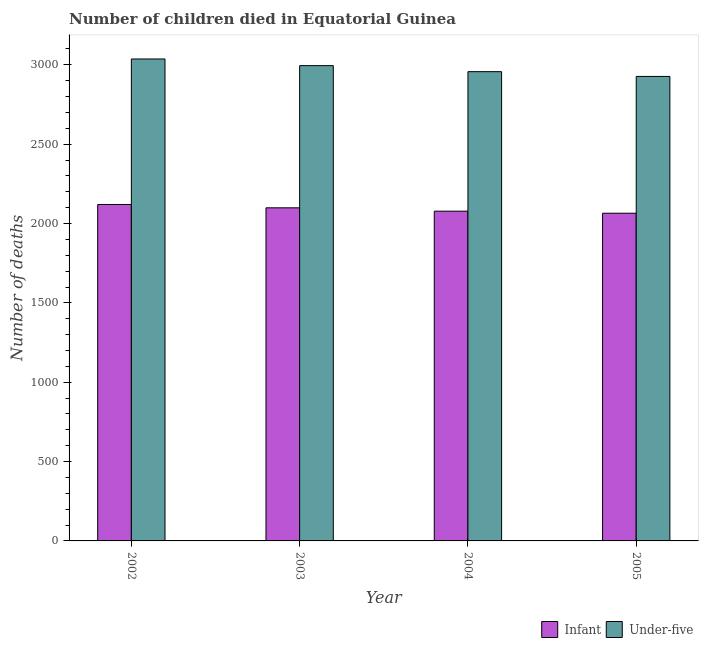How many different coloured bars are there?
Offer a very short reply. 2. How many groups of bars are there?
Make the answer very short. 4. What is the number of infant deaths in 2003?
Your answer should be very brief. 2099. Across all years, what is the maximum number of infant deaths?
Provide a succinct answer. 2120. Across all years, what is the minimum number of infant deaths?
Your response must be concise. 2065. In which year was the number of under-five deaths maximum?
Provide a succinct answer. 2002. In which year was the number of under-five deaths minimum?
Ensure brevity in your answer.  2005. What is the total number of infant deaths in the graph?
Give a very brief answer. 8362. What is the difference between the number of infant deaths in 2002 and that in 2004?
Ensure brevity in your answer.  42. What is the difference between the number of under-five deaths in 2005 and the number of infant deaths in 2004?
Keep it short and to the point. -30. What is the average number of infant deaths per year?
Offer a very short reply. 2090.5. In how many years, is the number of infant deaths greater than 2700?
Keep it short and to the point. 0. What is the ratio of the number of infant deaths in 2002 to that in 2003?
Your answer should be compact. 1.01. Is the difference between the number of infant deaths in 2003 and 2004 greater than the difference between the number of under-five deaths in 2003 and 2004?
Make the answer very short. No. What is the difference between the highest and the lowest number of infant deaths?
Make the answer very short. 55. Is the sum of the number of infant deaths in 2002 and 2005 greater than the maximum number of under-five deaths across all years?
Your answer should be compact. Yes. What does the 1st bar from the left in 2002 represents?
Give a very brief answer. Infant. What does the 1st bar from the right in 2003 represents?
Give a very brief answer. Under-five. Are the values on the major ticks of Y-axis written in scientific E-notation?
Make the answer very short. No. Does the graph contain any zero values?
Offer a terse response. No. Where does the legend appear in the graph?
Give a very brief answer. Bottom right. How many legend labels are there?
Keep it short and to the point. 2. What is the title of the graph?
Provide a succinct answer. Number of children died in Equatorial Guinea. What is the label or title of the Y-axis?
Your answer should be very brief. Number of deaths. What is the Number of deaths of Infant in 2002?
Keep it short and to the point. 2120. What is the Number of deaths in Under-five in 2002?
Keep it short and to the point. 3037. What is the Number of deaths of Infant in 2003?
Your answer should be very brief. 2099. What is the Number of deaths in Under-five in 2003?
Offer a terse response. 2995. What is the Number of deaths of Infant in 2004?
Make the answer very short. 2078. What is the Number of deaths in Under-five in 2004?
Provide a short and direct response. 2957. What is the Number of deaths of Infant in 2005?
Ensure brevity in your answer.  2065. What is the Number of deaths in Under-five in 2005?
Keep it short and to the point. 2927. Across all years, what is the maximum Number of deaths in Infant?
Your response must be concise. 2120. Across all years, what is the maximum Number of deaths of Under-five?
Make the answer very short. 3037. Across all years, what is the minimum Number of deaths in Infant?
Make the answer very short. 2065. Across all years, what is the minimum Number of deaths in Under-five?
Give a very brief answer. 2927. What is the total Number of deaths in Infant in the graph?
Provide a succinct answer. 8362. What is the total Number of deaths of Under-five in the graph?
Provide a succinct answer. 1.19e+04. What is the difference between the Number of deaths in Infant in 2002 and that in 2003?
Offer a terse response. 21. What is the difference between the Number of deaths of Infant in 2002 and that in 2005?
Make the answer very short. 55. What is the difference between the Number of deaths in Under-five in 2002 and that in 2005?
Keep it short and to the point. 110. What is the difference between the Number of deaths in Infant in 2003 and that in 2004?
Offer a very short reply. 21. What is the difference between the Number of deaths of Infant in 2003 and that in 2005?
Give a very brief answer. 34. What is the difference between the Number of deaths in Infant in 2004 and that in 2005?
Your answer should be very brief. 13. What is the difference between the Number of deaths in Under-five in 2004 and that in 2005?
Ensure brevity in your answer.  30. What is the difference between the Number of deaths in Infant in 2002 and the Number of deaths in Under-five in 2003?
Provide a short and direct response. -875. What is the difference between the Number of deaths of Infant in 2002 and the Number of deaths of Under-five in 2004?
Provide a succinct answer. -837. What is the difference between the Number of deaths in Infant in 2002 and the Number of deaths in Under-five in 2005?
Offer a terse response. -807. What is the difference between the Number of deaths in Infant in 2003 and the Number of deaths in Under-five in 2004?
Keep it short and to the point. -858. What is the difference between the Number of deaths of Infant in 2003 and the Number of deaths of Under-five in 2005?
Your response must be concise. -828. What is the difference between the Number of deaths of Infant in 2004 and the Number of deaths of Under-five in 2005?
Offer a very short reply. -849. What is the average Number of deaths in Infant per year?
Provide a succinct answer. 2090.5. What is the average Number of deaths in Under-five per year?
Offer a terse response. 2979. In the year 2002, what is the difference between the Number of deaths of Infant and Number of deaths of Under-five?
Make the answer very short. -917. In the year 2003, what is the difference between the Number of deaths of Infant and Number of deaths of Under-five?
Ensure brevity in your answer.  -896. In the year 2004, what is the difference between the Number of deaths in Infant and Number of deaths in Under-five?
Provide a short and direct response. -879. In the year 2005, what is the difference between the Number of deaths of Infant and Number of deaths of Under-five?
Your answer should be compact. -862. What is the ratio of the Number of deaths of Infant in 2002 to that in 2003?
Your answer should be compact. 1.01. What is the ratio of the Number of deaths of Under-five in 2002 to that in 2003?
Offer a very short reply. 1.01. What is the ratio of the Number of deaths of Infant in 2002 to that in 2004?
Your response must be concise. 1.02. What is the ratio of the Number of deaths in Under-five in 2002 to that in 2004?
Your response must be concise. 1.03. What is the ratio of the Number of deaths in Infant in 2002 to that in 2005?
Ensure brevity in your answer.  1.03. What is the ratio of the Number of deaths of Under-five in 2002 to that in 2005?
Provide a short and direct response. 1.04. What is the ratio of the Number of deaths of Infant in 2003 to that in 2004?
Your answer should be very brief. 1.01. What is the ratio of the Number of deaths in Under-five in 2003 to that in 2004?
Your response must be concise. 1.01. What is the ratio of the Number of deaths of Infant in 2003 to that in 2005?
Offer a very short reply. 1.02. What is the ratio of the Number of deaths of Under-five in 2003 to that in 2005?
Your response must be concise. 1.02. What is the ratio of the Number of deaths of Under-five in 2004 to that in 2005?
Make the answer very short. 1.01. What is the difference between the highest and the second highest Number of deaths in Under-five?
Offer a very short reply. 42. What is the difference between the highest and the lowest Number of deaths in Under-five?
Make the answer very short. 110. 